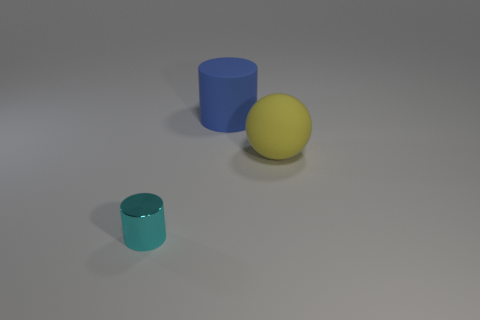Are there any yellow matte spheres? yes 